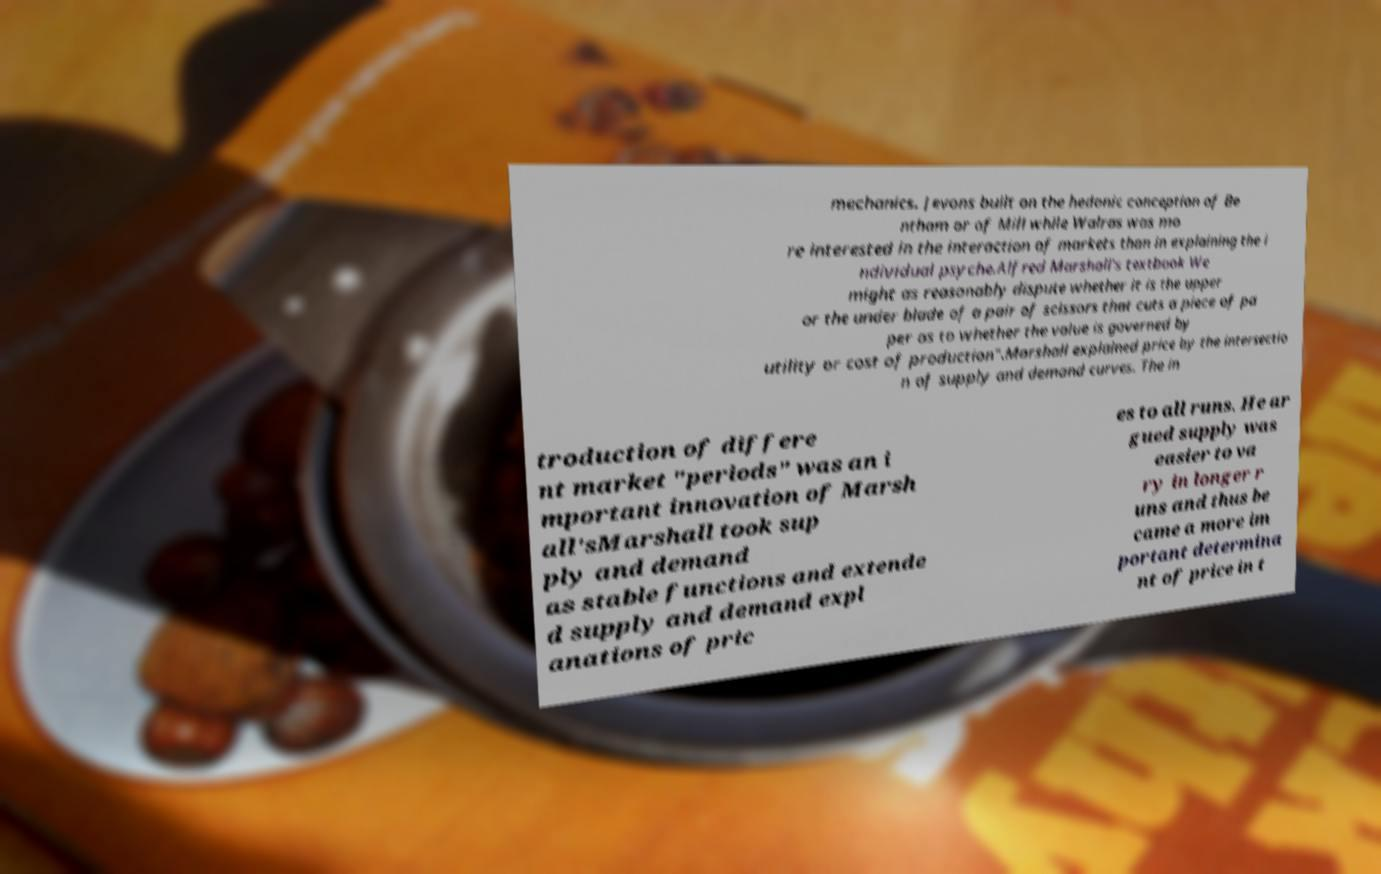Can you read and provide the text displayed in the image?This photo seems to have some interesting text. Can you extract and type it out for me? mechanics. Jevons built on the hedonic conception of Be ntham or of Mill while Walras was mo re interested in the interaction of markets than in explaining the i ndividual psyche.Alfred Marshall's textbook We might as reasonably dispute whether it is the upper or the under blade of a pair of scissors that cuts a piece of pa per as to whether the value is governed by utility or cost of production".Marshall explained price by the intersectio n of supply and demand curves. The in troduction of differe nt market "periods" was an i mportant innovation of Marsh all'sMarshall took sup ply and demand as stable functions and extende d supply and demand expl anations of pric es to all runs. He ar gued supply was easier to va ry in longer r uns and thus be came a more im portant determina nt of price in t 